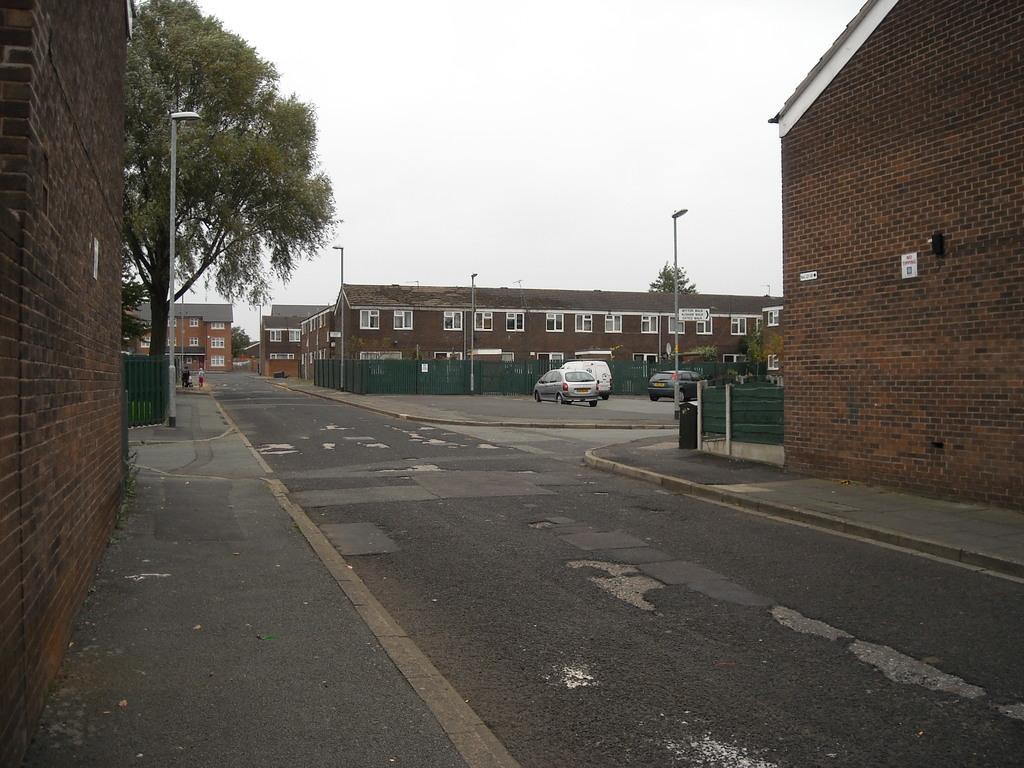Please provide a concise description of this image. In the foreground I can see buildings, light poles, fence, windows, trees, vehicles on the road and two persons. In the background I can see the sky. This image is taken may be during a day. 